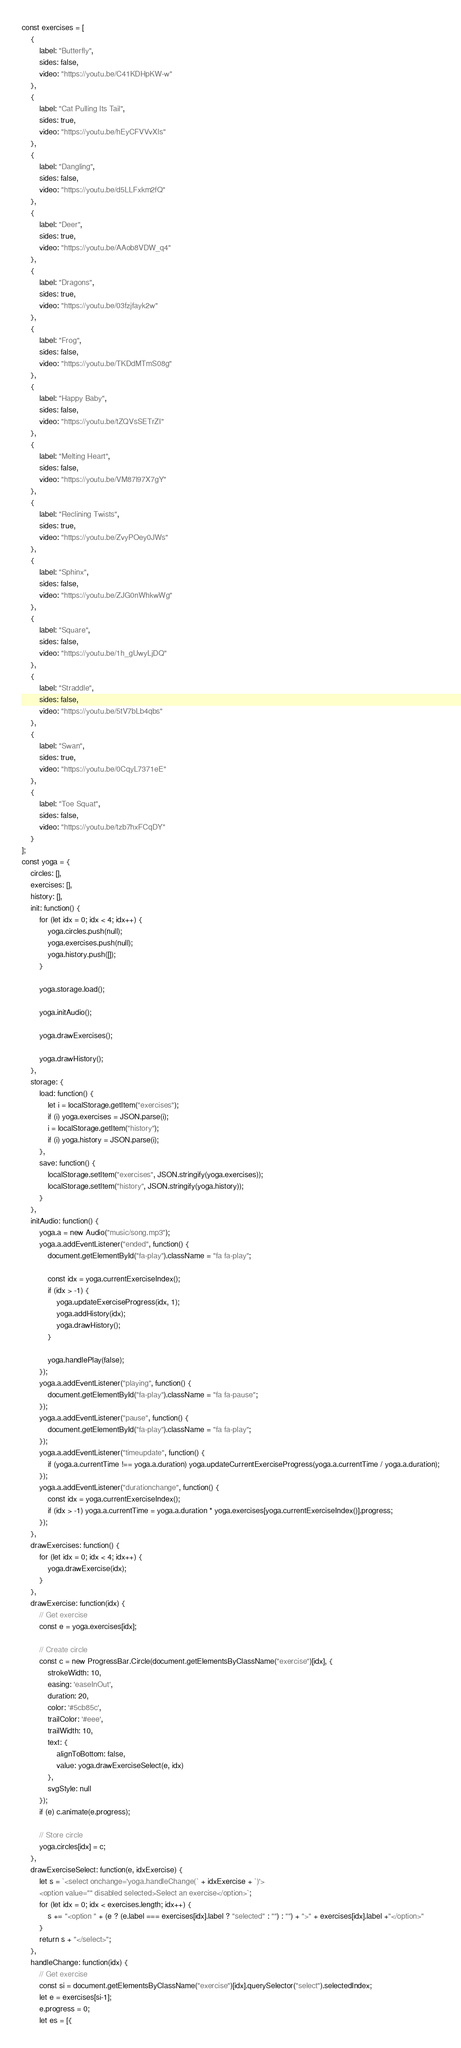<code> <loc_0><loc_0><loc_500><loc_500><_JavaScript_>const exercises = [
    {
        label: "Butterfly",
        sides: false,
        video: "https://youtu.be/C41KDHpKW-w"
    },
    {
        label: "Cat Pulling Its Tail",
        sides: true,
        video: "https://youtu.be/hEyCFVVvXls"
    },
    {
        label: "Dangling",
        sides: false,
        video: "https://youtu.be/d5LLFxkm2fQ"
    },
    {
        label: "Deer",
        sides: true,
        video: "https://youtu.be/AAob8VDW_q4"
    },
    {
        label: "Dragons",
        sides: true,
        video: "https://youtu.be/03fzjfayk2w"
    },
    {
        label: "Frog",
        sides: false,
        video: "https://youtu.be/TKDdMTmS08g"
    },
    {
        label: "Happy Baby",
        sides: false,
        video: "https://youtu.be/tZQVsSETrZI"
    },
    {
        label: "Melting Heart",
        sides: false,
        video: "https://youtu.be/VM87l97X7gY"
    },
    {
        label: "Reclining Twists",
        sides: true,
        video: "https://youtu.be/ZvyPOey0JWs"
    },
    {
        label: "Sphinx",
        sides: false,
        video: "https://youtu.be/ZJG0nWhkwWg"
    },
    {
        label: "Square",
        sides: false,
        video: "https://youtu.be/1h_gUwyLjDQ"
    },
    {
        label: "Straddle",
        sides: false,
        video: "https://youtu.be/5tV7bLb4qbs"
    },
    {
        label: "Swan",
        sides: true,
        video: "https://youtu.be/0CqyL7371eE"
    },
    {
        label: "Toe Squat",
        sides: false,
        video: "https://youtu.be/tzb7hxFCqDY"
    }
];
const yoga = {
    circles: [],
    exercises: [],
    history: [],
    init: function() {
        for (let idx = 0; idx < 4; idx++) {
            yoga.circles.push(null);
            yoga.exercises.push(null);
            yoga.history.push([]);
        }

        yoga.storage.load();

        yoga.initAudio();

        yoga.drawExercises();

        yoga.drawHistory();
    },
    storage: {
        load: function() {
            let i = localStorage.getItem("exercises");
            if (i) yoga.exercises = JSON.parse(i);
            i = localStorage.getItem("history");
            if (i) yoga.history = JSON.parse(i);
        },
        save: function() {
            localStorage.setItem("exercises", JSON.stringify(yoga.exercises));
            localStorage.setItem("history", JSON.stringify(yoga.history));
        }
    },
    initAudio: function() {
        yoga.a = new Audio("music/song.mp3");
        yoga.a.addEventListener("ended", function() {
            document.getElementById("fa-play").className = "fa fa-play";

            const idx = yoga.currentExerciseIndex();
            if (idx > -1) {
                yoga.updateExerciseProgress(idx, 1);
                yoga.addHistory(idx);
                yoga.drawHistory();
            }

            yoga.handlePlay(false);
        });
        yoga.a.addEventListener("playing", function() {
            document.getElementById("fa-play").className = "fa fa-pause";
        });
        yoga.a.addEventListener("pause", function() {
            document.getElementById("fa-play").className = "fa fa-play";
        });
        yoga.a.addEventListener("timeupdate", function() {
            if (yoga.a.currentTime !== yoga.a.duration) yoga.updateCurrentExerciseProgress(yoga.a.currentTime / yoga.a.duration);
        });
        yoga.a.addEventListener("durationchange", function() {
            const idx = yoga.currentExerciseIndex();
            if (idx > -1) yoga.a.currentTime = yoga.a.duration * yoga.exercises[yoga.currentExerciseIndex()].progress;
        });
    },
    drawExercises: function() {
        for (let idx = 0; idx < 4; idx++) {
            yoga.drawExercise(idx);
        }
    },
    drawExercise: function(idx) {
        // Get exercise
        const e = yoga.exercises[idx];

        // Create circle
        const c = new ProgressBar.Circle(document.getElementsByClassName("exercise")[idx], {
            strokeWidth: 10,
            easing: 'easeInOut',
            duration: 20,
            color: '#5cb85c',
            trailColor: '#eee',
            trailWidth: 10,
            text: {
                alignToBottom: false,
                value: yoga.drawExerciseSelect(e, idx)
            },
            svgStyle: null
        });
        if (e) c.animate(e.progress);

        // Store circle
        yoga.circles[idx] = c;
    },
    drawExerciseSelect: function(e, idxExercise) {
        let s = `<select onchange='yoga.handleChange(` + idxExercise + `)'>
        <option value="" disabled selected>Select an exercise</option>`;
        for (let idx = 0; idx < exercises.length; idx++) {
            s += "<option " + (e ? (e.label === exercises[idx].label ? "selected" : "") : "") + ">" + exercises[idx].label +"</option>"
        }
        return s + "</select>";
    },
    handleChange: function(idx) {
        // Get exercise
        const si = document.getElementsByClassName("exercise")[idx].querySelector("select").selectedIndex;
        let e = exercises[si-1];
        e.progress = 0;
        let es = [{</code> 